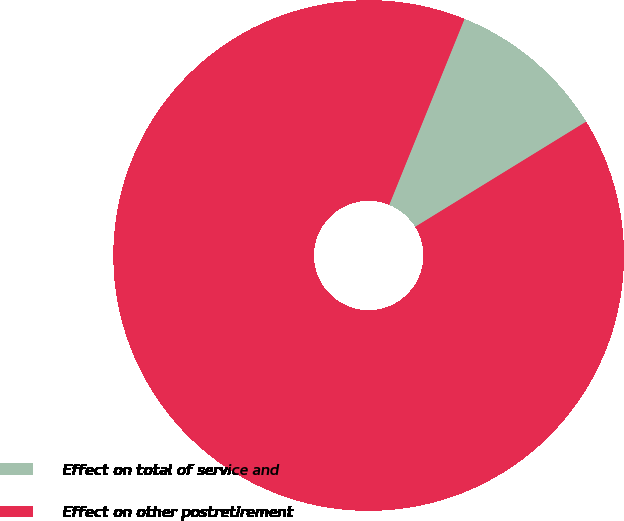<chart> <loc_0><loc_0><loc_500><loc_500><pie_chart><fcel>Effect on total of service and<fcel>Effect on other postretirement<nl><fcel>10.1%<fcel>89.9%<nl></chart> 